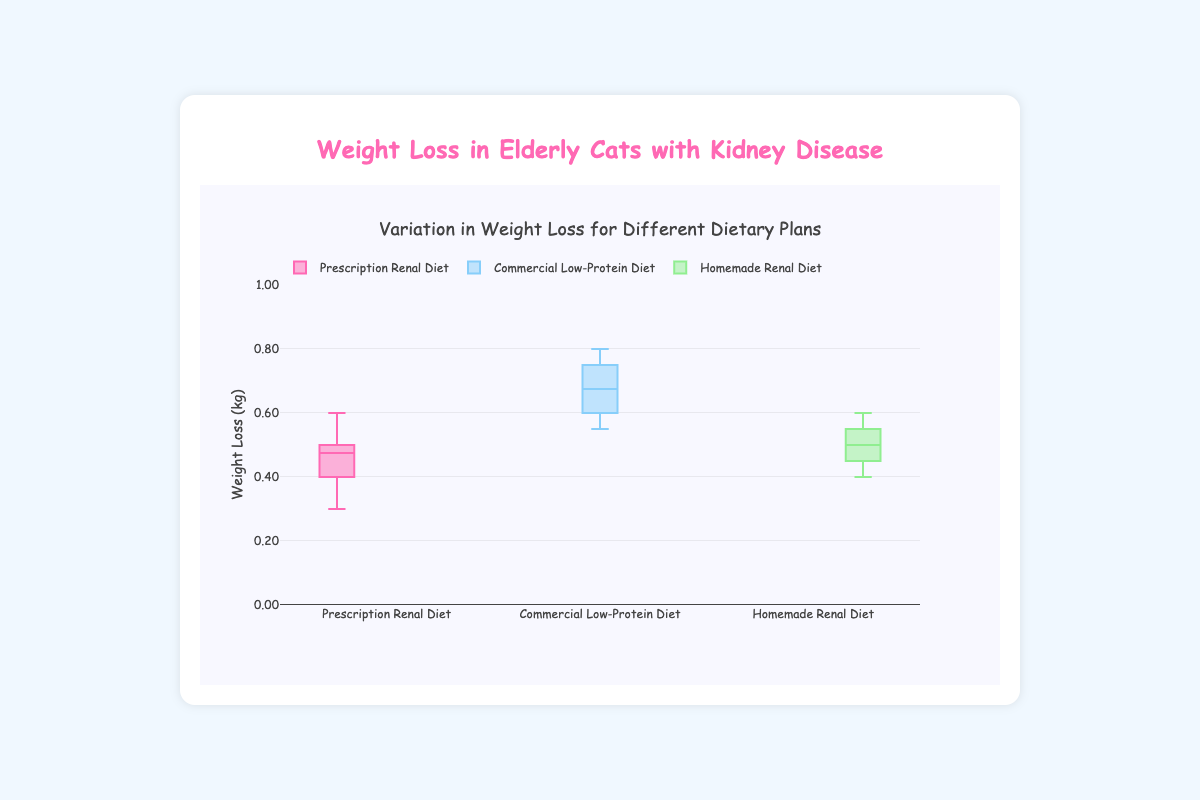What is the title of the figure? The title is displayed at the top of the figure. It helps to understand the context or subject of the data presented in the plot.
Answer: Weight Loss in Elderly Cats with Kidney Disease What is the range of weight loss for the Prescription Renal Diet? The range of the weight loss can be observed from the bottom to the top of the box plot for the Prescription Renal Diet.
Answer: 0.3 to 0.6 kg Which dietary plan has the highest median weight loss? To determine which dietary plan has the highest median weight loss, we look at the central line in each box plot and compare their positions.
Answer: Commercial Low-Protein Diet How does the weight loss for the Homemade Renal Diet compare to the Prescription Renal Diet? We look at the spread and center of the box plots for both diets. The Homemade Renal Diet has a slightly higher upper limit but has similar weight loss as the Prescription Renal Diet.
Answer: Similar, but slightly higher upper limit What does the middle line inside each box represent? The middle line inside each box in the box plot represents the median weight loss value for that dietary plan.
Answer: Median weight loss Which dietary plan shows the greatest variation in weight loss among elderly cats? To find the greatest variation, we compare the height (range) of each box plot from the lowest to the highest weight loss values.
Answer: Commercial Low-Protein Diet How many different dietary plans are compared in the figure? The figure shows separate box plots for each dietary plan, and we can count the number of these distinct groups.
Answer: 3 What is the interquartile range (IQR) for the Homemade Renal Diet? The interquartile range is the difference between the third quartile (top of the box) and the first quartile (bottom of the box) for the Homemade Renal Diet box plot.
Answer: 0.15 kg How does the outlier detection differ among the plots? To detect outliers, we would look for any points that lie outside the whiskers of each box plot. In this figure, it appears there are no outliers visibly marked outside the whiskers.
Answer: No visible outliers 